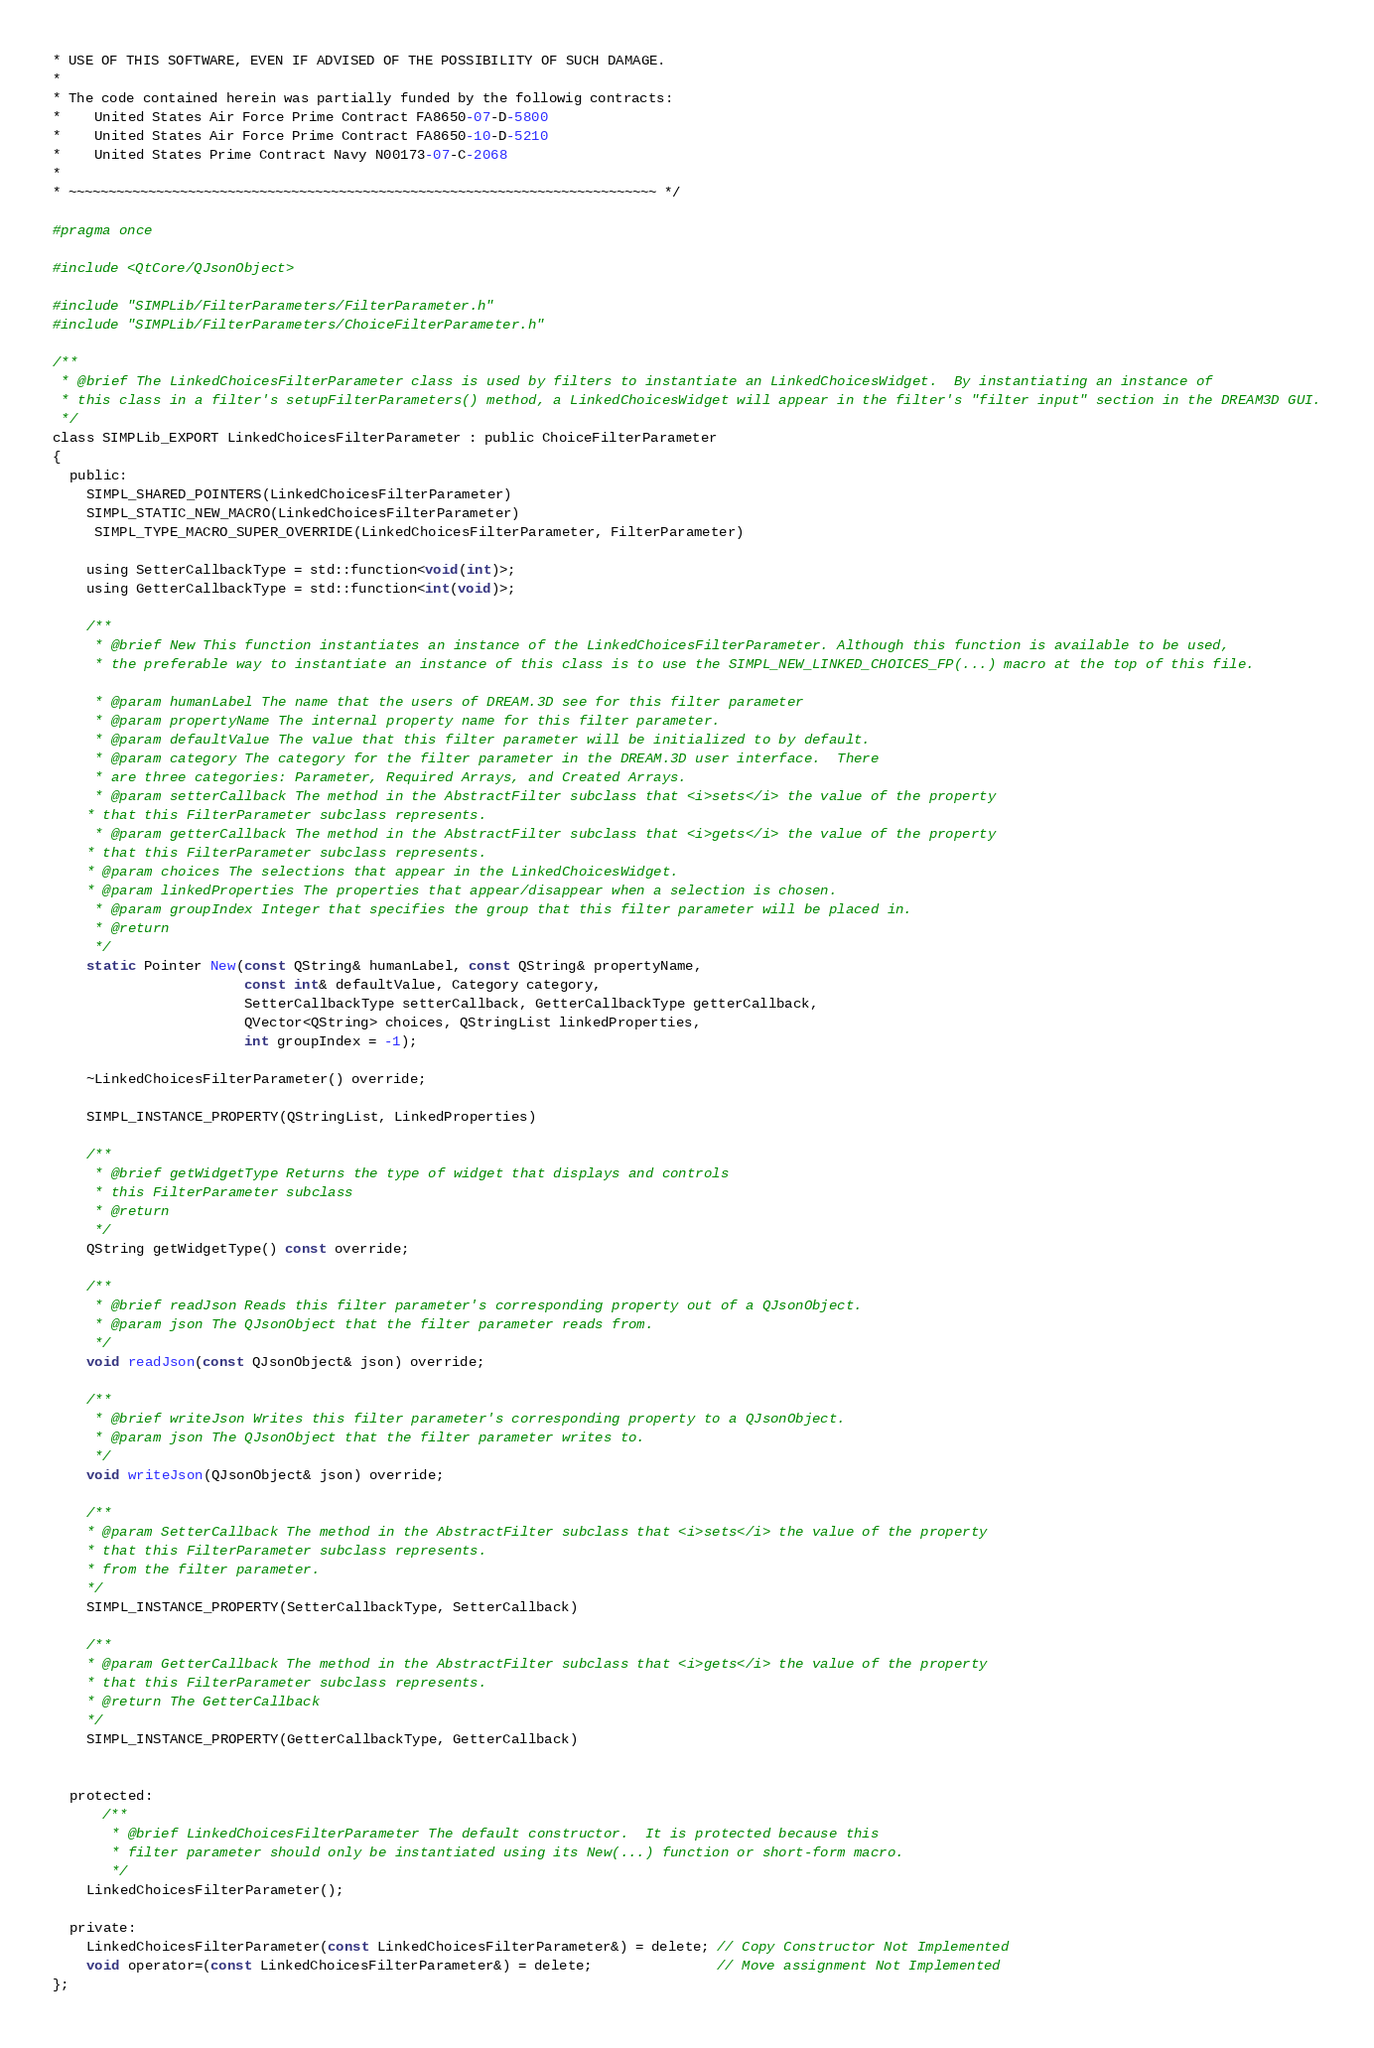Convert code to text. <code><loc_0><loc_0><loc_500><loc_500><_C_>* USE OF THIS SOFTWARE, EVEN IF ADVISED OF THE POSSIBILITY OF SUCH DAMAGE.
*
* The code contained herein was partially funded by the followig contracts:
*    United States Air Force Prime Contract FA8650-07-D-5800
*    United States Air Force Prime Contract FA8650-10-D-5210
*    United States Prime Contract Navy N00173-07-C-2068
*
* ~~~~~~~~~~~~~~~~~~~~~~~~~~~~~~~~~~~~~~~~~~~~~~~~~~~~~~~~~~~~~~~~~~~~~~~~~~ */

#pragma once

#include <QtCore/QJsonObject>

#include "SIMPLib/FilterParameters/FilterParameter.h"
#include "SIMPLib/FilterParameters/ChoiceFilterParameter.h"

/**
 * @brief The LinkedChoicesFilterParameter class is used by filters to instantiate an LinkedChoicesWidget.  By instantiating an instance of
 * this class in a filter's setupFilterParameters() method, a LinkedChoicesWidget will appear in the filter's "filter input" section in the DREAM3D GUI.
 */
class SIMPLib_EXPORT LinkedChoicesFilterParameter : public ChoiceFilterParameter
{
  public:
    SIMPL_SHARED_POINTERS(LinkedChoicesFilterParameter)
    SIMPL_STATIC_NEW_MACRO(LinkedChoicesFilterParameter)
     SIMPL_TYPE_MACRO_SUPER_OVERRIDE(LinkedChoicesFilterParameter, FilterParameter)

    using SetterCallbackType = std::function<void(int)>;
    using GetterCallbackType = std::function<int(void)>;

    /**
     * @brief New This function instantiates an instance of the LinkedChoicesFilterParameter. Although this function is available to be used,
     * the preferable way to instantiate an instance of this class is to use the SIMPL_NEW_LINKED_CHOICES_FP(...) macro at the top of this file.

     * @param humanLabel The name that the users of DREAM.3D see for this filter parameter
     * @param propertyName The internal property name for this filter parameter.
     * @param defaultValue The value that this filter parameter will be initialized to by default.
     * @param category The category for the filter parameter in the DREAM.3D user interface.  There
     * are three categories: Parameter, Required Arrays, and Created Arrays.
     * @param setterCallback The method in the AbstractFilter subclass that <i>sets</i> the value of the property
    * that this FilterParameter subclass represents.
     * @param getterCallback The method in the AbstractFilter subclass that <i>gets</i> the value of the property
    * that this FilterParameter subclass represents.
    * @param choices The selections that appear in the LinkedChoicesWidget.
    * @param linkedProperties The properties that appear/disappear when a selection is chosen.
     * @param groupIndex Integer that specifies the group that this filter parameter will be placed in.
     * @return
     */
    static Pointer New(const QString& humanLabel, const QString& propertyName,
                       const int& defaultValue, Category category,
                       SetterCallbackType setterCallback, GetterCallbackType getterCallback,
                       QVector<QString> choices, QStringList linkedProperties,
                       int groupIndex = -1);

    ~LinkedChoicesFilterParameter() override;

    SIMPL_INSTANCE_PROPERTY(QStringList, LinkedProperties)

    /**
     * @brief getWidgetType Returns the type of widget that displays and controls
     * this FilterParameter subclass
     * @return
     */
    QString getWidgetType() const override;

    /**
     * @brief readJson Reads this filter parameter's corresponding property out of a QJsonObject.
     * @param json The QJsonObject that the filter parameter reads from.
     */
    void readJson(const QJsonObject& json) override;

    /**
     * @brief writeJson Writes this filter parameter's corresponding property to a QJsonObject.
     * @param json The QJsonObject that the filter parameter writes to.
     */
    void writeJson(QJsonObject& json) override;

    /**
    * @param SetterCallback The method in the AbstractFilter subclass that <i>sets</i> the value of the property
    * that this FilterParameter subclass represents.
    * from the filter parameter.
    */
    SIMPL_INSTANCE_PROPERTY(SetterCallbackType, SetterCallback)

    /**
    * @param GetterCallback The method in the AbstractFilter subclass that <i>gets</i> the value of the property
    * that this FilterParameter subclass represents.
    * @return The GetterCallback
    */
    SIMPL_INSTANCE_PROPERTY(GetterCallbackType, GetterCallback)


  protected:
      /**
       * @brief LinkedChoicesFilterParameter The default constructor.  It is protected because this
       * filter parameter should only be instantiated using its New(...) function or short-form macro.
       */
    LinkedChoicesFilterParameter();

  private:
    LinkedChoicesFilterParameter(const LinkedChoicesFilterParameter&) = delete; // Copy Constructor Not Implemented
    void operator=(const LinkedChoicesFilterParameter&) = delete;               // Move assignment Not Implemented
};

</code> 